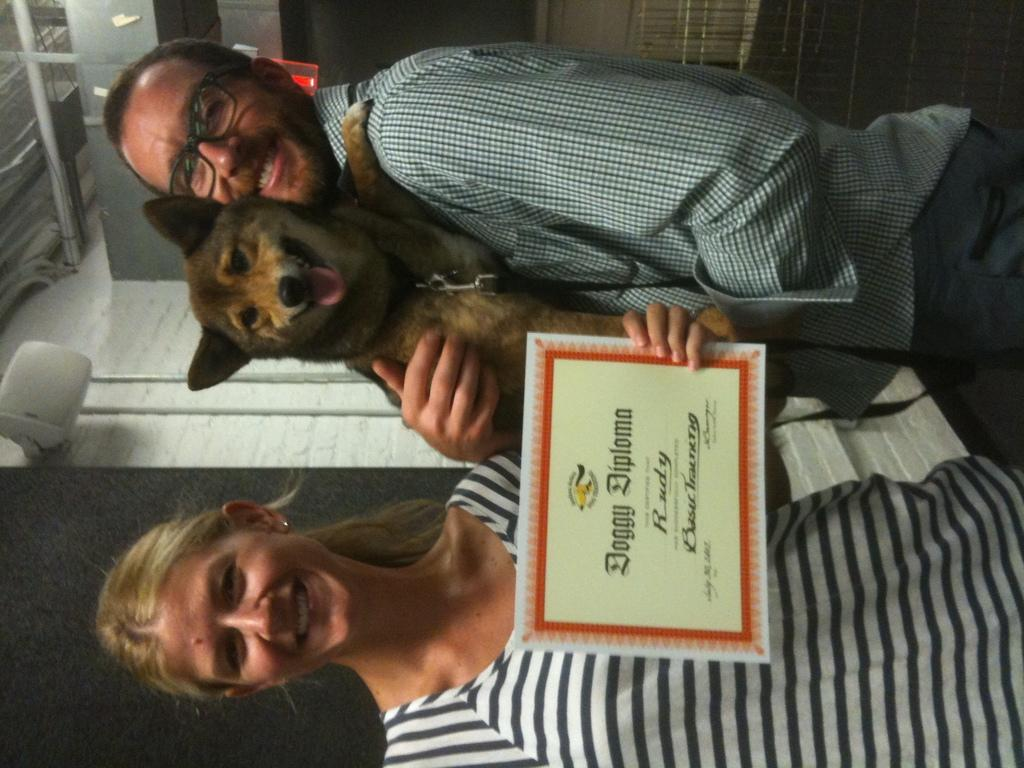How many people are in the image? There are two people in the image, a man and a woman. What is the woman doing in the image? The woman is standing in the image. What is the man holding in the image? The man is holding a dog in his hands. What type of fog can be seen in the image? There is no fog present in the image. What color is the cabbage that the man is holding in the image? The man is not holding a cabbage in the image; he is holding a dog. 